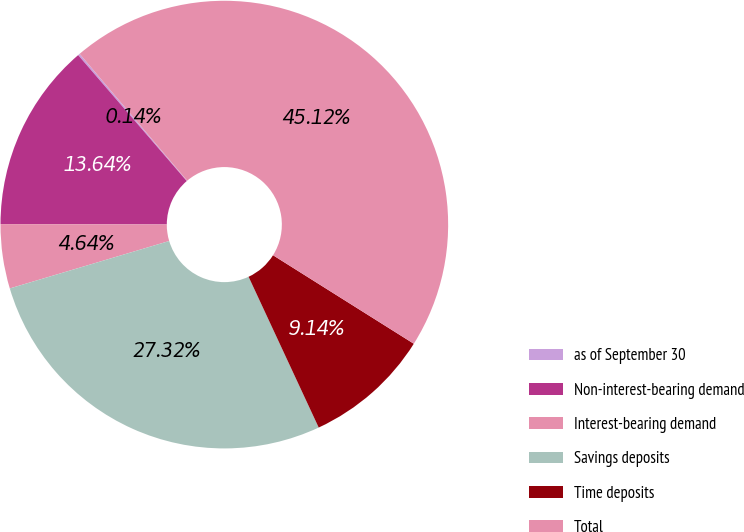Convert chart. <chart><loc_0><loc_0><loc_500><loc_500><pie_chart><fcel>as of September 30<fcel>Non-interest-bearing demand<fcel>Interest-bearing demand<fcel>Savings deposits<fcel>Time deposits<fcel>Total<nl><fcel>0.14%<fcel>13.64%<fcel>4.64%<fcel>27.33%<fcel>9.14%<fcel>45.13%<nl></chart> 